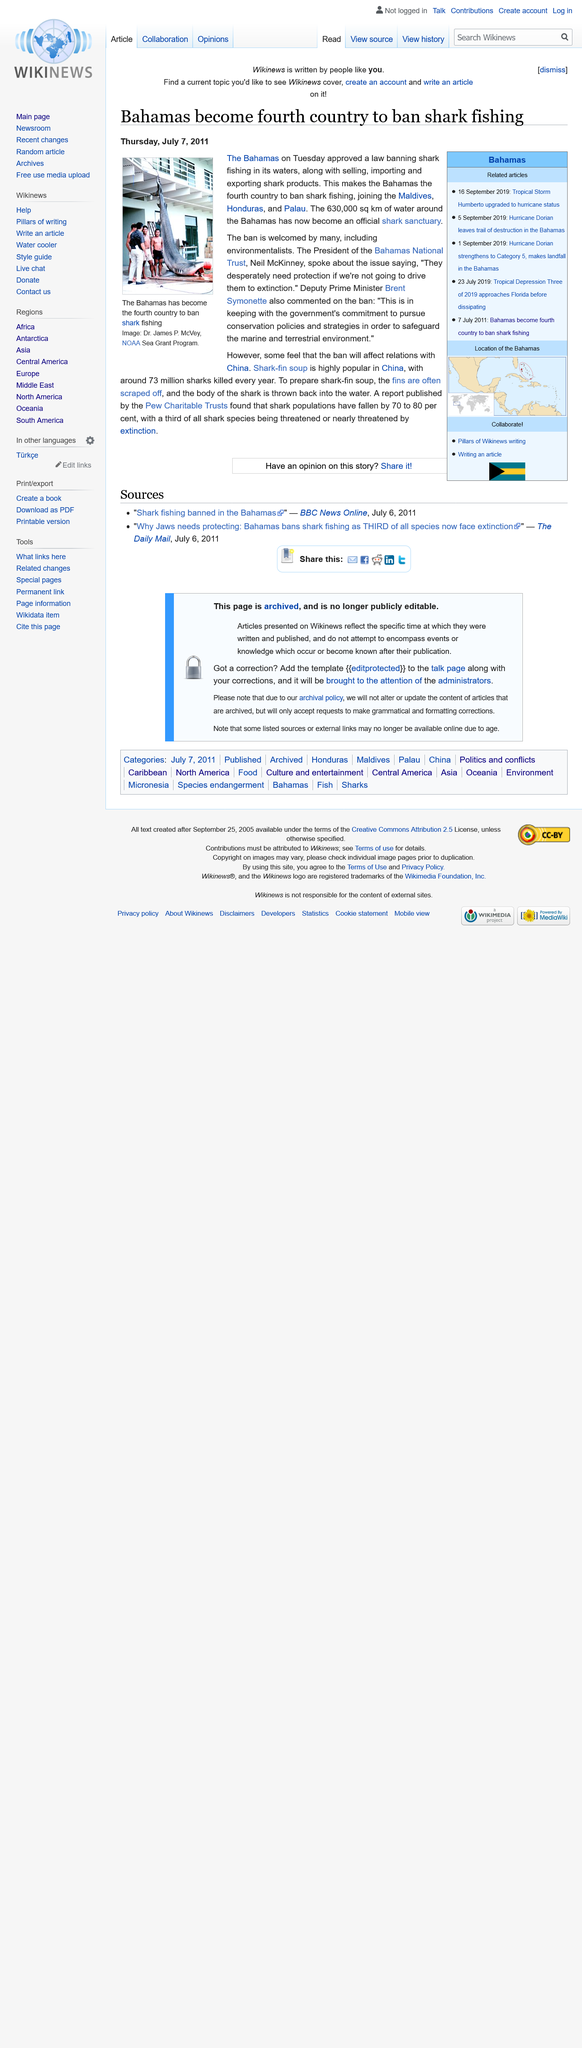List a handful of essential elements in this visual. The Maldives, Honduras, and Palau have banned shark fishing in their respective countries, making them four out of five countries that have taken this conservation-oriented measure. Neil McKinney is the President of the Bahamas National Trust. The animal depicted in the photograph is a shark. 